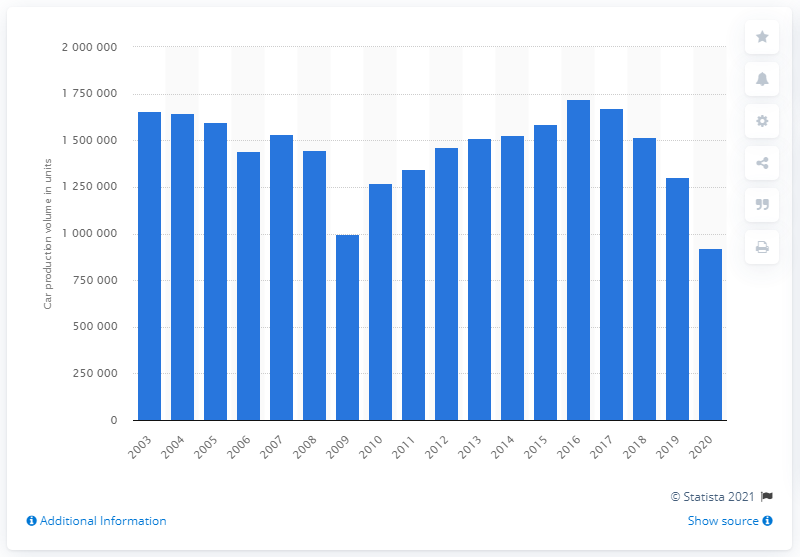Indicate a few pertinent items in this graphic. In 2009, the passenger car production in the United Kingdom experienced the greatest decline. 